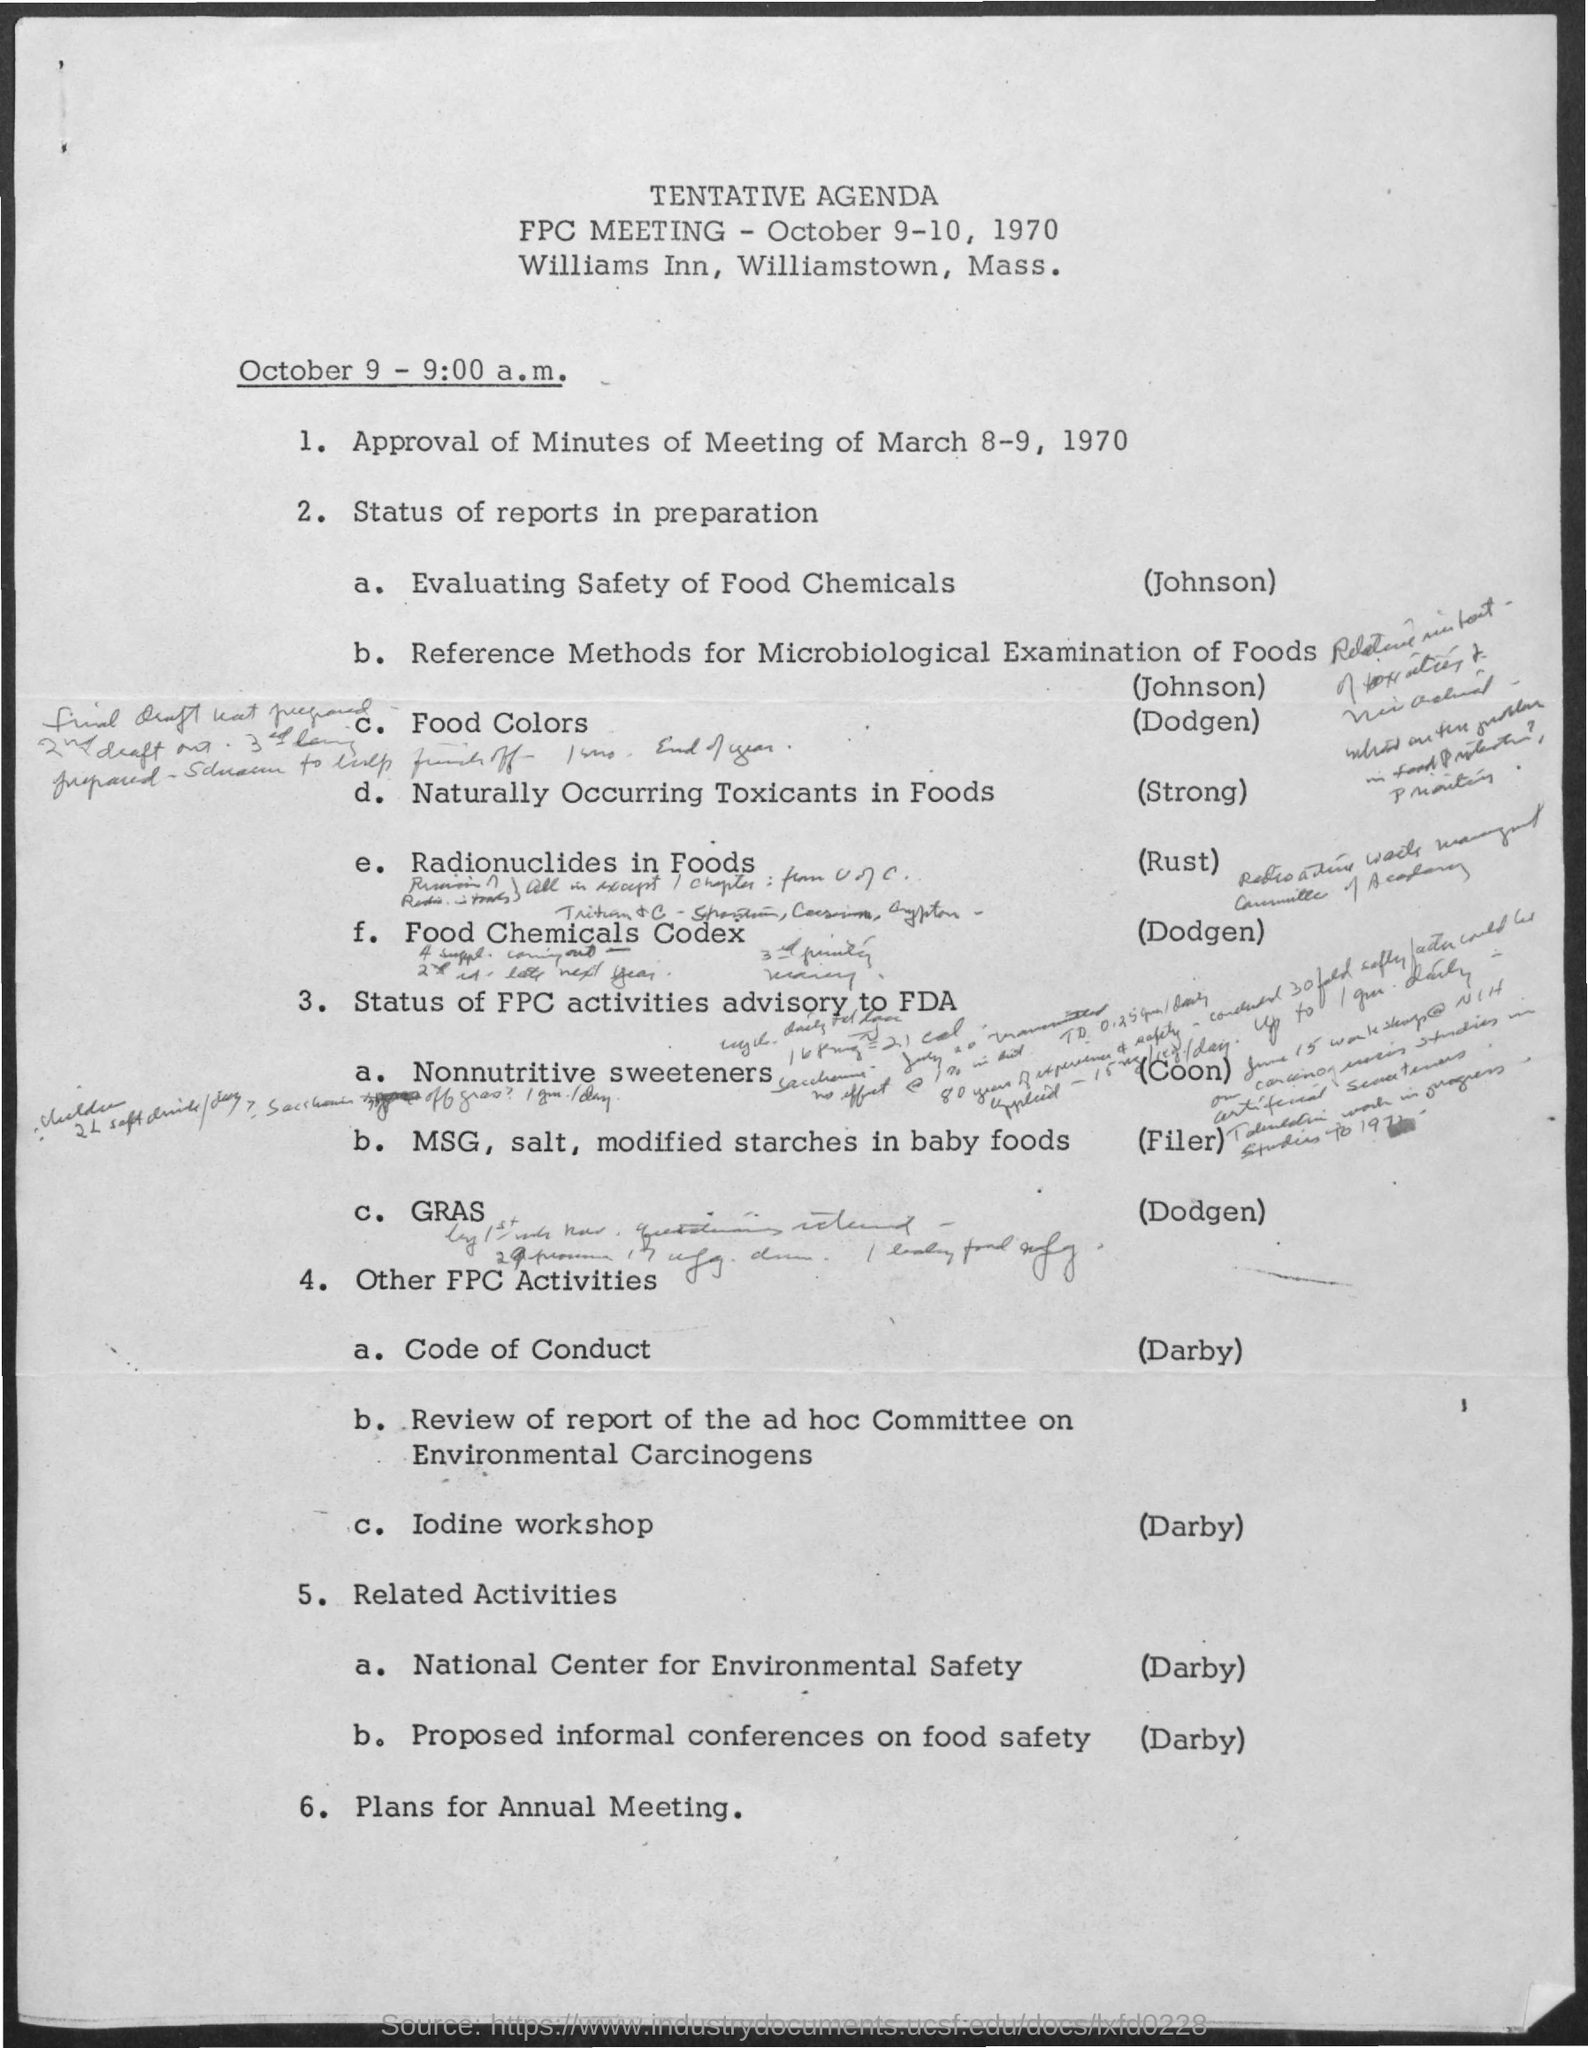What are the dates scheduled for the given meetings ?
Offer a terse response. October 9-10 , 1970. What is the name of the meeting mentioned in the given agenda ?
Keep it short and to the point. FPC meeting. By whom the evaluating safety of food chemicals was done in the given agenda ?
Provide a short and direct response. Johnson. 